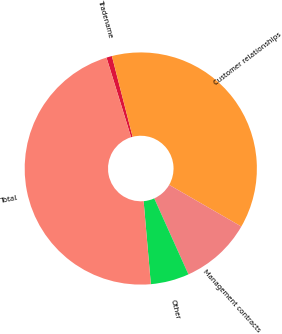<chart> <loc_0><loc_0><loc_500><loc_500><pie_chart><fcel>Tradename<fcel>Customer relationships<fcel>Management contracts<fcel>Other<fcel>Total<nl><fcel>0.77%<fcel>37.33%<fcel>9.94%<fcel>5.35%<fcel>46.61%<nl></chart> 